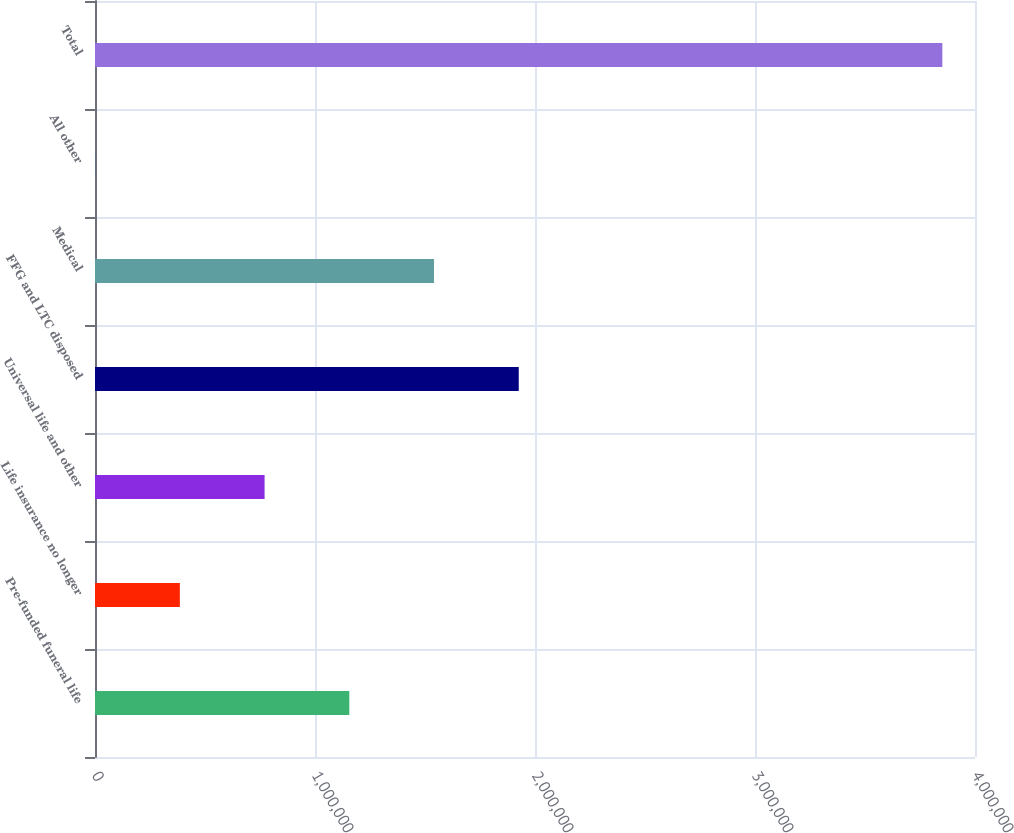<chart> <loc_0><loc_0><loc_500><loc_500><bar_chart><fcel>Pre-funded funeral life<fcel>Life insurance no longer<fcel>Universal life and other<fcel>FFG and LTC disposed<fcel>Medical<fcel>All other<fcel>Total<nl><fcel>1.15591e+06<fcel>385709<fcel>770809<fcel>1.92611e+06<fcel>1.54101e+06<fcel>608<fcel>3.85161e+06<nl></chart> 